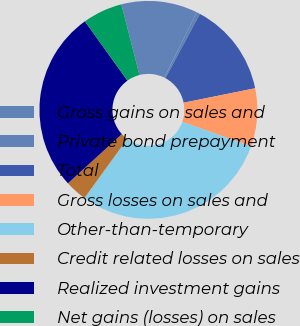<chart> <loc_0><loc_0><loc_500><loc_500><pie_chart><fcel>Gross gains on sales and<fcel>Private bond prepayment<fcel>Total<fcel>Gross losses on sales and<fcel>Other-than-temporary<fcel>Credit related losses on sales<fcel>Realized investment gains<fcel>Net gains (losses) on sales<nl><fcel>11.29%<fcel>0.54%<fcel>13.98%<fcel>8.6%<fcel>29.57%<fcel>3.23%<fcel>26.88%<fcel>5.91%<nl></chart> 